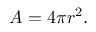<formula> <loc_0><loc_0><loc_500><loc_500>\, A = 4 \pi r ^ { 2 } .</formula> 